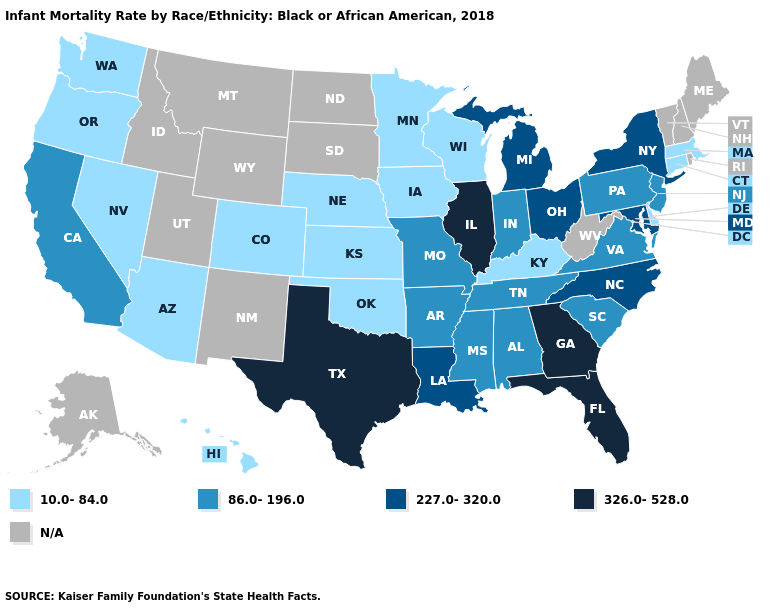What is the value of Iowa?
Concise answer only. 10.0-84.0. Does Arizona have the highest value in the USA?
Concise answer only. No. Among the states that border New Jersey , which have the lowest value?
Short answer required. Delaware. Name the states that have a value in the range 86.0-196.0?
Give a very brief answer. Alabama, Arkansas, California, Indiana, Mississippi, Missouri, New Jersey, Pennsylvania, South Carolina, Tennessee, Virginia. What is the value of Washington?
Be succinct. 10.0-84.0. Name the states that have a value in the range 86.0-196.0?
Answer briefly. Alabama, Arkansas, California, Indiana, Mississippi, Missouri, New Jersey, Pennsylvania, South Carolina, Tennessee, Virginia. Name the states that have a value in the range 227.0-320.0?
Keep it brief. Louisiana, Maryland, Michigan, New York, North Carolina, Ohio. Name the states that have a value in the range N/A?
Be succinct. Alaska, Idaho, Maine, Montana, New Hampshire, New Mexico, North Dakota, Rhode Island, South Dakota, Utah, Vermont, West Virginia, Wyoming. What is the lowest value in states that border Mississippi?
Answer briefly. 86.0-196.0. What is the highest value in the Northeast ?
Concise answer only. 227.0-320.0. Name the states that have a value in the range 326.0-528.0?
Short answer required. Florida, Georgia, Illinois, Texas. What is the lowest value in the USA?
Short answer required. 10.0-84.0. Name the states that have a value in the range 326.0-528.0?
Concise answer only. Florida, Georgia, Illinois, Texas. Name the states that have a value in the range 86.0-196.0?
Give a very brief answer. Alabama, Arkansas, California, Indiana, Mississippi, Missouri, New Jersey, Pennsylvania, South Carolina, Tennessee, Virginia. What is the highest value in the South ?
Answer briefly. 326.0-528.0. 